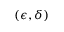Convert formula to latex. <formula><loc_0><loc_0><loc_500><loc_500>( \epsilon , \delta )</formula> 